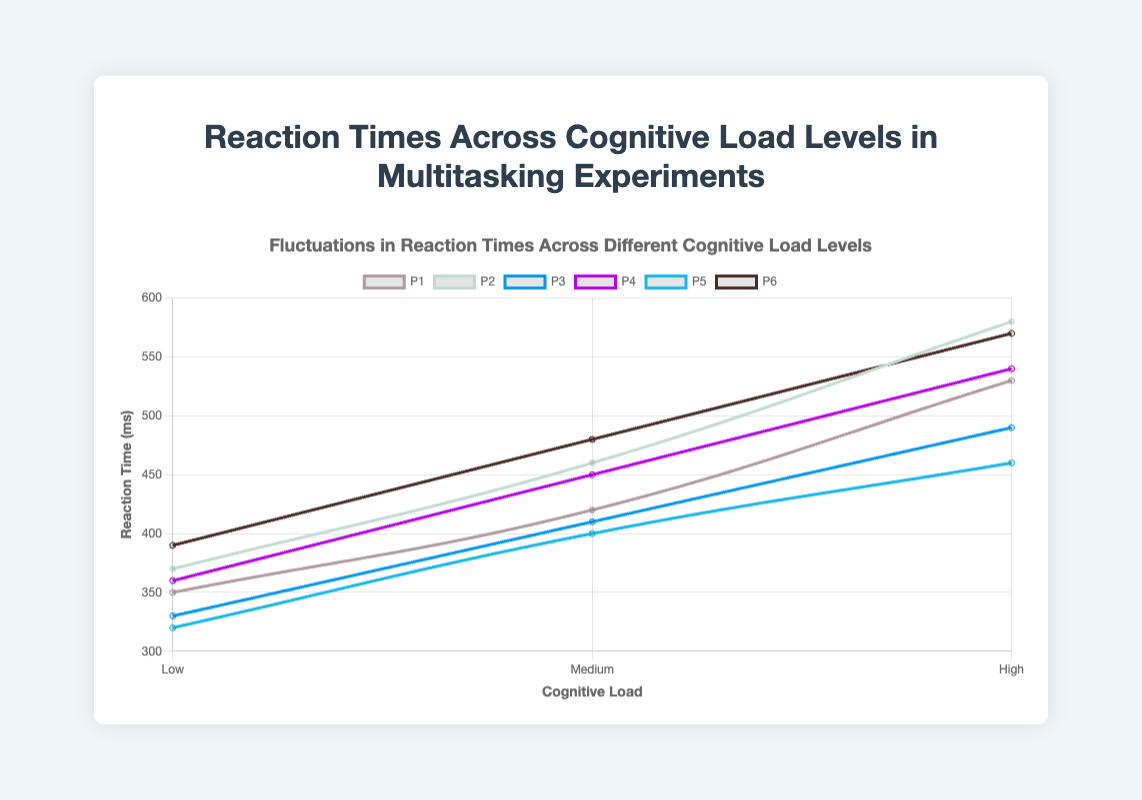What is the trend in reaction times as cognitive load increases for Participant P1? By observing the plotted line for Participant P1, you can see it starts at a lower point under Low cognitive load, then increases at Medium cognitive load, and increases further at High cognitive load. This upward trend indicates that for P1, reaction times increase with higher cognitive load levels
Answer: Reaction times increase with higher cognitive load Which participant had the highest reaction time under High cognitive load? To answer this, you need to look at the highest peak on the rightmost side of the plot, corresponding to High cognitive load. By comparing the peaks for each participant, you can identify that P2 has the highest value under High cognitive load, which is 580 ms
Answer: P2 What is the average reaction time for Participant P3 across all cognitive load levels? First, extract the reaction times for Participant P3: 330 ms (Low), 410 ms (Medium), and 490 ms (High). Sum these values: 330 + 410 + 490 = 1230 ms. Then divide by the number of levels (3): 1230 / 3 = 410 ms
Answer: 410 ms How does the reaction time under Medium cognitive load for Participant P5 compare to the reaction time under Low cognitive load for Participant P6? The reaction time for Participant P5 under Medium cognitive load is 400 ms. The reaction time for Participant P6 under Low cognitive load is 390 ms. Comparing the two, 400 ms is greater than 390 ms.
Answer: 400 ms > 390 ms Which participant shows the smallest increase in reaction time from Low to Medium cognitive load? Find the difference between Medium and Low reaction times for each participant. P1: 420-350=70 ms, P2: 460-370=90 ms, P3: 410-330=80 ms, P4: 450-360=90 ms, P5: 400-320=80 ms, P6: 480-390=90 ms. The smallest increase is 70 ms by P1
Answer: P1 What is the total reaction time combined for all participants under Low cognitive load? Sum the reaction times for all participants under Low cognitive load: 350 + 370 + 330 + 360 + 320 + 390 = 2120 ms
Answer: 2120 ms Which cognitive load level shows the greatest variation in reaction times across participants? To assess variation, observe the spread of points for each cognitive load level. High cognitive load has the most significant range of reaction times, ranging from 460 ms to 580 ms, indicating the greatest variation among participants
Answer: High What is the visual difference in line steepness between P1 and P5 from Medium to High cognitive load? The line steepness represents the rate of change in reaction times. By visually comparing the slopes of the lines from Medium to High load for both P1 and P5, P1 shows a steeper increase (420 to 530 ms) than P5 (400 to 460 ms)
Answer: P1's line is steeper 